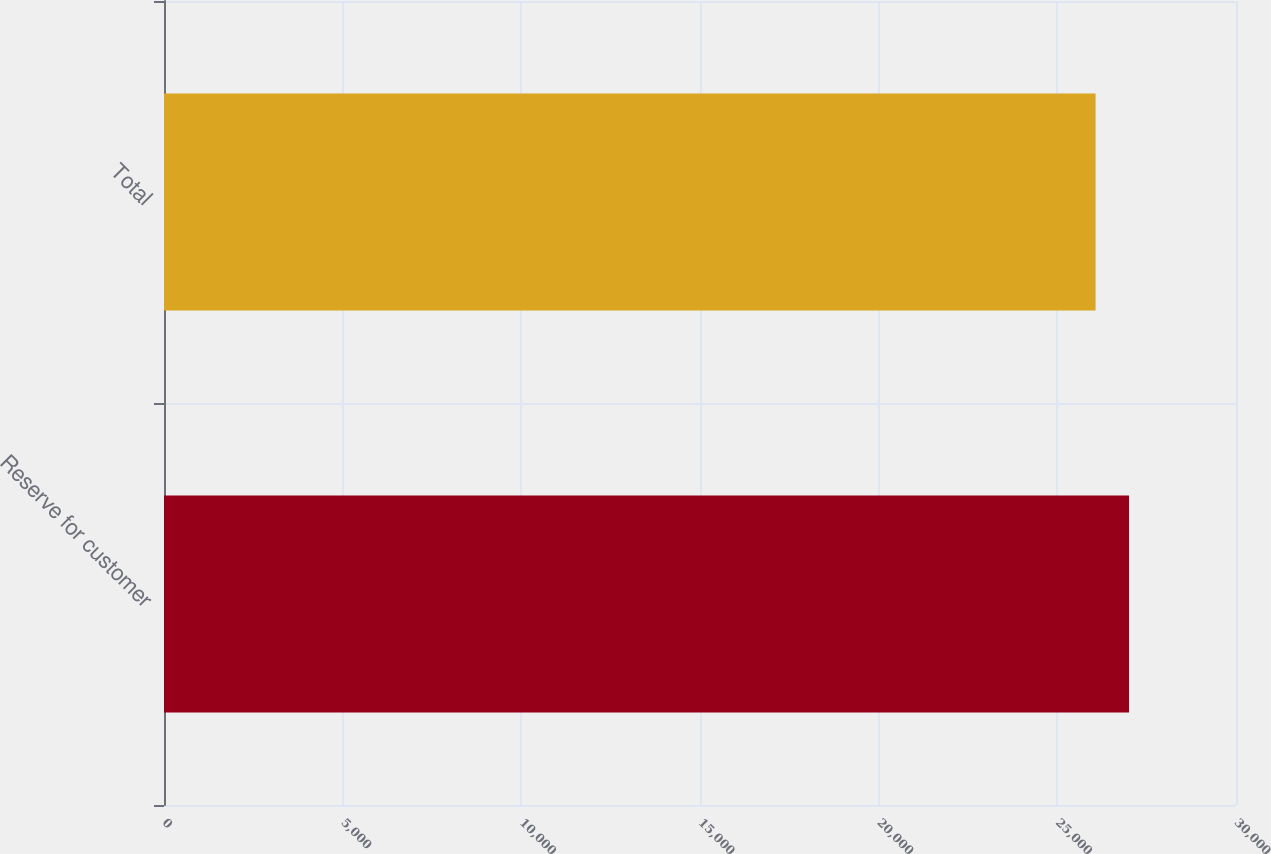Convert chart. <chart><loc_0><loc_0><loc_500><loc_500><bar_chart><fcel>Reserve for customer<fcel>Total<nl><fcel>27007<fcel>26070<nl></chart> 